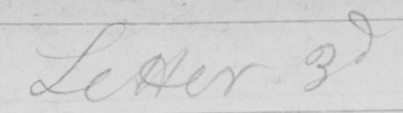Can you tell me what this handwritten text says? Letter 3d 